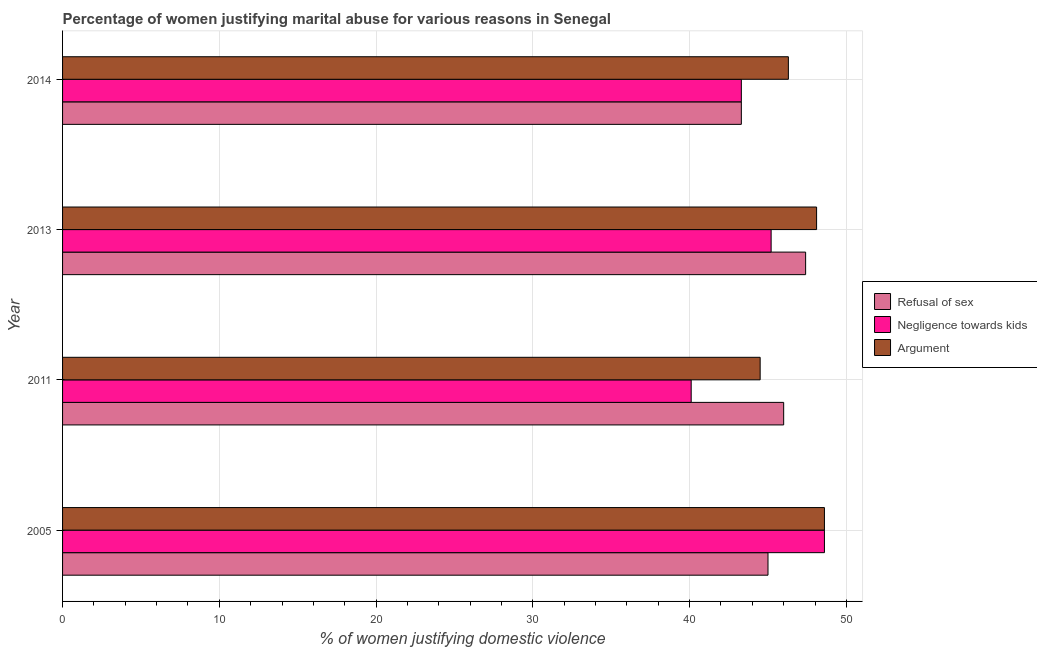How many different coloured bars are there?
Your answer should be very brief. 3. How many groups of bars are there?
Your response must be concise. 4. In how many cases, is the number of bars for a given year not equal to the number of legend labels?
Provide a succinct answer. 0. What is the percentage of women justifying domestic violence due to negligence towards kids in 2013?
Ensure brevity in your answer.  45.2. Across all years, what is the maximum percentage of women justifying domestic violence due to negligence towards kids?
Provide a succinct answer. 48.6. Across all years, what is the minimum percentage of women justifying domestic violence due to arguments?
Provide a short and direct response. 44.5. In which year was the percentage of women justifying domestic violence due to negligence towards kids maximum?
Provide a short and direct response. 2005. In which year was the percentage of women justifying domestic violence due to arguments minimum?
Provide a short and direct response. 2011. What is the total percentage of women justifying domestic violence due to refusal of sex in the graph?
Keep it short and to the point. 181.7. What is the difference between the percentage of women justifying domestic violence due to arguments in 2005 and that in 2013?
Keep it short and to the point. 0.5. What is the difference between the percentage of women justifying domestic violence due to arguments in 2014 and the percentage of women justifying domestic violence due to refusal of sex in 2011?
Offer a terse response. 0.3. What is the average percentage of women justifying domestic violence due to refusal of sex per year?
Your answer should be compact. 45.42. What is the ratio of the percentage of women justifying domestic violence due to arguments in 2005 to that in 2014?
Offer a very short reply. 1.05. Is the percentage of women justifying domestic violence due to arguments in 2011 less than that in 2013?
Give a very brief answer. Yes. What does the 2nd bar from the top in 2014 represents?
Keep it short and to the point. Negligence towards kids. What does the 2nd bar from the bottom in 2013 represents?
Your answer should be compact. Negligence towards kids. How many bars are there?
Your answer should be compact. 12. How many years are there in the graph?
Provide a succinct answer. 4. Does the graph contain any zero values?
Provide a short and direct response. No. Where does the legend appear in the graph?
Provide a succinct answer. Center right. How many legend labels are there?
Give a very brief answer. 3. What is the title of the graph?
Your response must be concise. Percentage of women justifying marital abuse for various reasons in Senegal. What is the label or title of the X-axis?
Provide a short and direct response. % of women justifying domestic violence. What is the label or title of the Y-axis?
Keep it short and to the point. Year. What is the % of women justifying domestic violence in Negligence towards kids in 2005?
Ensure brevity in your answer.  48.6. What is the % of women justifying domestic violence in Argument in 2005?
Ensure brevity in your answer.  48.6. What is the % of women justifying domestic violence of Negligence towards kids in 2011?
Your answer should be very brief. 40.1. What is the % of women justifying domestic violence of Argument in 2011?
Keep it short and to the point. 44.5. What is the % of women justifying domestic violence of Refusal of sex in 2013?
Ensure brevity in your answer.  47.4. What is the % of women justifying domestic violence of Negligence towards kids in 2013?
Provide a short and direct response. 45.2. What is the % of women justifying domestic violence in Argument in 2013?
Offer a very short reply. 48.1. What is the % of women justifying domestic violence of Refusal of sex in 2014?
Offer a terse response. 43.3. What is the % of women justifying domestic violence in Negligence towards kids in 2014?
Make the answer very short. 43.3. What is the % of women justifying domestic violence of Argument in 2014?
Offer a very short reply. 46.3. Across all years, what is the maximum % of women justifying domestic violence of Refusal of sex?
Keep it short and to the point. 47.4. Across all years, what is the maximum % of women justifying domestic violence of Negligence towards kids?
Make the answer very short. 48.6. Across all years, what is the maximum % of women justifying domestic violence of Argument?
Offer a very short reply. 48.6. Across all years, what is the minimum % of women justifying domestic violence of Refusal of sex?
Your answer should be compact. 43.3. Across all years, what is the minimum % of women justifying domestic violence in Negligence towards kids?
Your answer should be very brief. 40.1. Across all years, what is the minimum % of women justifying domestic violence in Argument?
Give a very brief answer. 44.5. What is the total % of women justifying domestic violence of Refusal of sex in the graph?
Provide a succinct answer. 181.7. What is the total % of women justifying domestic violence in Negligence towards kids in the graph?
Your answer should be very brief. 177.2. What is the total % of women justifying domestic violence in Argument in the graph?
Ensure brevity in your answer.  187.5. What is the difference between the % of women justifying domestic violence of Refusal of sex in 2005 and that in 2011?
Provide a succinct answer. -1. What is the difference between the % of women justifying domestic violence of Negligence towards kids in 2005 and that in 2011?
Your answer should be very brief. 8.5. What is the difference between the % of women justifying domestic violence of Argument in 2005 and that in 2011?
Provide a succinct answer. 4.1. What is the difference between the % of women justifying domestic violence in Refusal of sex in 2005 and that in 2013?
Your answer should be compact. -2.4. What is the difference between the % of women justifying domestic violence of Negligence towards kids in 2005 and that in 2013?
Give a very brief answer. 3.4. What is the difference between the % of women justifying domestic violence of Refusal of sex in 2005 and that in 2014?
Your response must be concise. 1.7. What is the difference between the % of women justifying domestic violence of Negligence towards kids in 2005 and that in 2014?
Your answer should be compact. 5.3. What is the difference between the % of women justifying domestic violence in Refusal of sex in 2011 and that in 2013?
Provide a succinct answer. -1.4. What is the difference between the % of women justifying domestic violence in Argument in 2011 and that in 2013?
Your answer should be very brief. -3.6. What is the difference between the % of women justifying domestic violence of Negligence towards kids in 2011 and that in 2014?
Provide a short and direct response. -3.2. What is the difference between the % of women justifying domestic violence in Argument in 2011 and that in 2014?
Provide a short and direct response. -1.8. What is the difference between the % of women justifying domestic violence of Refusal of sex in 2013 and that in 2014?
Give a very brief answer. 4.1. What is the difference between the % of women justifying domestic violence of Argument in 2013 and that in 2014?
Provide a short and direct response. 1.8. What is the difference between the % of women justifying domestic violence of Refusal of sex in 2005 and the % of women justifying domestic violence of Negligence towards kids in 2011?
Your answer should be very brief. 4.9. What is the difference between the % of women justifying domestic violence of Negligence towards kids in 2005 and the % of women justifying domestic violence of Argument in 2011?
Ensure brevity in your answer.  4.1. What is the difference between the % of women justifying domestic violence of Refusal of sex in 2005 and the % of women justifying domestic violence of Negligence towards kids in 2013?
Your answer should be very brief. -0.2. What is the difference between the % of women justifying domestic violence of Refusal of sex in 2005 and the % of women justifying domestic violence of Argument in 2014?
Offer a terse response. -1.3. What is the difference between the % of women justifying domestic violence of Negligence towards kids in 2005 and the % of women justifying domestic violence of Argument in 2014?
Provide a succinct answer. 2.3. What is the difference between the % of women justifying domestic violence in Refusal of sex in 2011 and the % of women justifying domestic violence in Negligence towards kids in 2013?
Offer a terse response. 0.8. What is the difference between the % of women justifying domestic violence of Refusal of sex in 2011 and the % of women justifying domestic violence of Argument in 2013?
Make the answer very short. -2.1. What is the difference between the % of women justifying domestic violence in Refusal of sex in 2011 and the % of women justifying domestic violence in Argument in 2014?
Provide a succinct answer. -0.3. What is the difference between the % of women justifying domestic violence in Negligence towards kids in 2011 and the % of women justifying domestic violence in Argument in 2014?
Give a very brief answer. -6.2. What is the average % of women justifying domestic violence in Refusal of sex per year?
Your answer should be very brief. 45.42. What is the average % of women justifying domestic violence of Negligence towards kids per year?
Keep it short and to the point. 44.3. What is the average % of women justifying domestic violence of Argument per year?
Offer a terse response. 46.88. In the year 2005, what is the difference between the % of women justifying domestic violence in Refusal of sex and % of women justifying domestic violence in Argument?
Your answer should be very brief. -3.6. In the year 2005, what is the difference between the % of women justifying domestic violence in Negligence towards kids and % of women justifying domestic violence in Argument?
Your answer should be compact. 0. In the year 2011, what is the difference between the % of women justifying domestic violence of Refusal of sex and % of women justifying domestic violence of Argument?
Offer a terse response. 1.5. In the year 2013, what is the difference between the % of women justifying domestic violence of Refusal of sex and % of women justifying domestic violence of Argument?
Offer a terse response. -0.7. In the year 2014, what is the difference between the % of women justifying domestic violence in Refusal of sex and % of women justifying domestic violence in Argument?
Make the answer very short. -3. In the year 2014, what is the difference between the % of women justifying domestic violence of Negligence towards kids and % of women justifying domestic violence of Argument?
Your response must be concise. -3. What is the ratio of the % of women justifying domestic violence of Refusal of sex in 2005 to that in 2011?
Provide a short and direct response. 0.98. What is the ratio of the % of women justifying domestic violence in Negligence towards kids in 2005 to that in 2011?
Offer a terse response. 1.21. What is the ratio of the % of women justifying domestic violence in Argument in 2005 to that in 2011?
Offer a terse response. 1.09. What is the ratio of the % of women justifying domestic violence of Refusal of sex in 2005 to that in 2013?
Keep it short and to the point. 0.95. What is the ratio of the % of women justifying domestic violence in Negligence towards kids in 2005 to that in 2013?
Provide a short and direct response. 1.08. What is the ratio of the % of women justifying domestic violence in Argument in 2005 to that in 2013?
Offer a terse response. 1.01. What is the ratio of the % of women justifying domestic violence of Refusal of sex in 2005 to that in 2014?
Provide a short and direct response. 1.04. What is the ratio of the % of women justifying domestic violence in Negligence towards kids in 2005 to that in 2014?
Provide a short and direct response. 1.12. What is the ratio of the % of women justifying domestic violence of Argument in 2005 to that in 2014?
Provide a succinct answer. 1.05. What is the ratio of the % of women justifying domestic violence of Refusal of sex in 2011 to that in 2013?
Provide a succinct answer. 0.97. What is the ratio of the % of women justifying domestic violence of Negligence towards kids in 2011 to that in 2013?
Provide a short and direct response. 0.89. What is the ratio of the % of women justifying domestic violence of Argument in 2011 to that in 2013?
Your response must be concise. 0.93. What is the ratio of the % of women justifying domestic violence in Refusal of sex in 2011 to that in 2014?
Your response must be concise. 1.06. What is the ratio of the % of women justifying domestic violence of Negligence towards kids in 2011 to that in 2014?
Offer a very short reply. 0.93. What is the ratio of the % of women justifying domestic violence of Argument in 2011 to that in 2014?
Ensure brevity in your answer.  0.96. What is the ratio of the % of women justifying domestic violence in Refusal of sex in 2013 to that in 2014?
Keep it short and to the point. 1.09. What is the ratio of the % of women justifying domestic violence of Negligence towards kids in 2013 to that in 2014?
Offer a terse response. 1.04. What is the ratio of the % of women justifying domestic violence in Argument in 2013 to that in 2014?
Offer a terse response. 1.04. What is the difference between the highest and the second highest % of women justifying domestic violence in Negligence towards kids?
Ensure brevity in your answer.  3.4. What is the difference between the highest and the second highest % of women justifying domestic violence in Argument?
Keep it short and to the point. 0.5. What is the difference between the highest and the lowest % of women justifying domestic violence in Refusal of sex?
Provide a short and direct response. 4.1. What is the difference between the highest and the lowest % of women justifying domestic violence of Negligence towards kids?
Give a very brief answer. 8.5. 